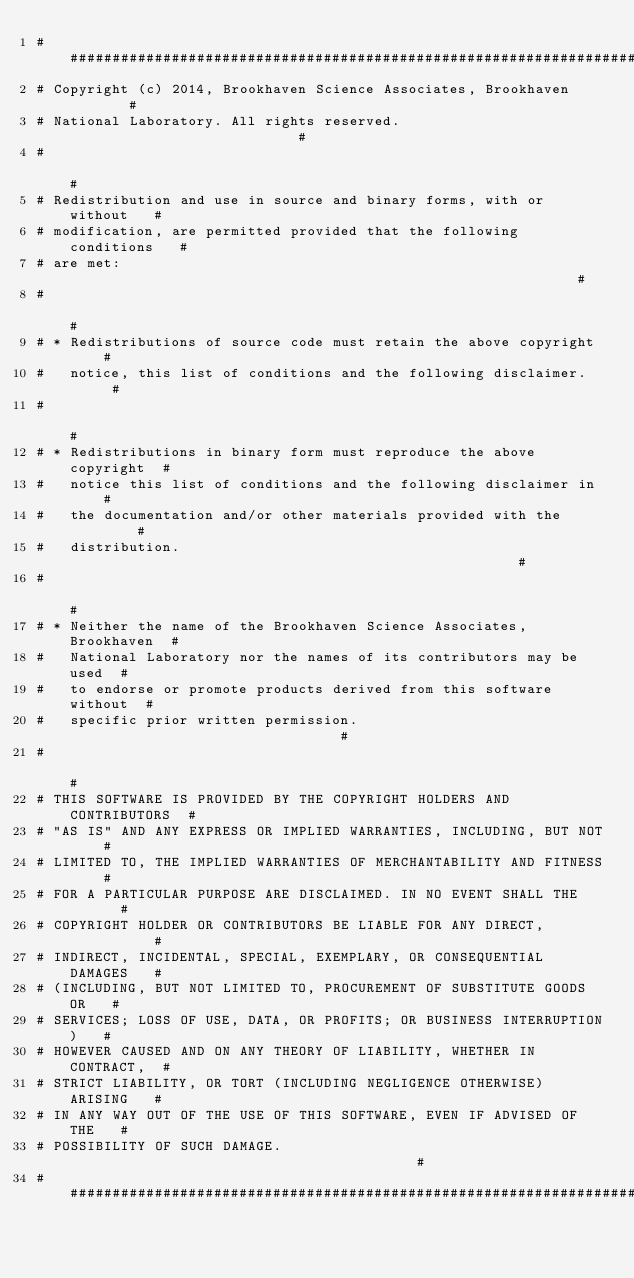Convert code to text. <code><loc_0><loc_0><loc_500><loc_500><_Python_># ######################################################################
# Copyright (c) 2014, Brookhaven Science Associates, Brookhaven        #
# National Laboratory. All rights reserved.                            #
#                                                                      #
# Redistribution and use in source and binary forms, with or without   #
# modification, are permitted provided that the following conditions   #
# are met:                                                             #
#                                                                      #
# * Redistributions of source code must retain the above copyright     #
#   notice, this list of conditions and the following disclaimer.      #
#                                                                      #
# * Redistributions in binary form must reproduce the above copyright  #
#   notice this list of conditions and the following disclaimer in     #
#   the documentation and/or other materials provided with the         #
#   distribution.                                                      #
#                                                                      #
# * Neither the name of the Brookhaven Science Associates, Brookhaven  #
#   National Laboratory nor the names of its contributors may be used  #
#   to endorse or promote products derived from this software without  #
#   specific prior written permission.                                 #
#                                                                      #
# THIS SOFTWARE IS PROVIDED BY THE COPYRIGHT HOLDERS AND CONTRIBUTORS  #
# "AS IS" AND ANY EXPRESS OR IMPLIED WARRANTIES, INCLUDING, BUT NOT    #
# LIMITED TO, THE IMPLIED WARRANTIES OF MERCHANTABILITY AND FITNESS    #
# FOR A PARTICULAR PURPOSE ARE DISCLAIMED. IN NO EVENT SHALL THE       #
# COPYRIGHT HOLDER OR CONTRIBUTORS BE LIABLE FOR ANY DIRECT,           #
# INDIRECT, INCIDENTAL, SPECIAL, EXEMPLARY, OR CONSEQUENTIAL DAMAGES   #
# (INCLUDING, BUT NOT LIMITED TO, PROCUREMENT OF SUBSTITUTE GOODS OR   #
# SERVICES; LOSS OF USE, DATA, OR PROFITS; OR BUSINESS INTERRUPTION)   #
# HOWEVER CAUSED AND ON ANY THEORY OF LIABILITY, WHETHER IN CONTRACT,  #
# STRICT LIABILITY, OR TORT (INCLUDING NEGLIGENCE OTHERWISE) ARISING   #
# IN ANY WAY OUT OF THE USE OF THIS SOFTWARE, EVEN IF ADVISED OF THE   #
# POSSIBILITY OF SUCH DAMAGE.                                          #
########################################################################
</code> 